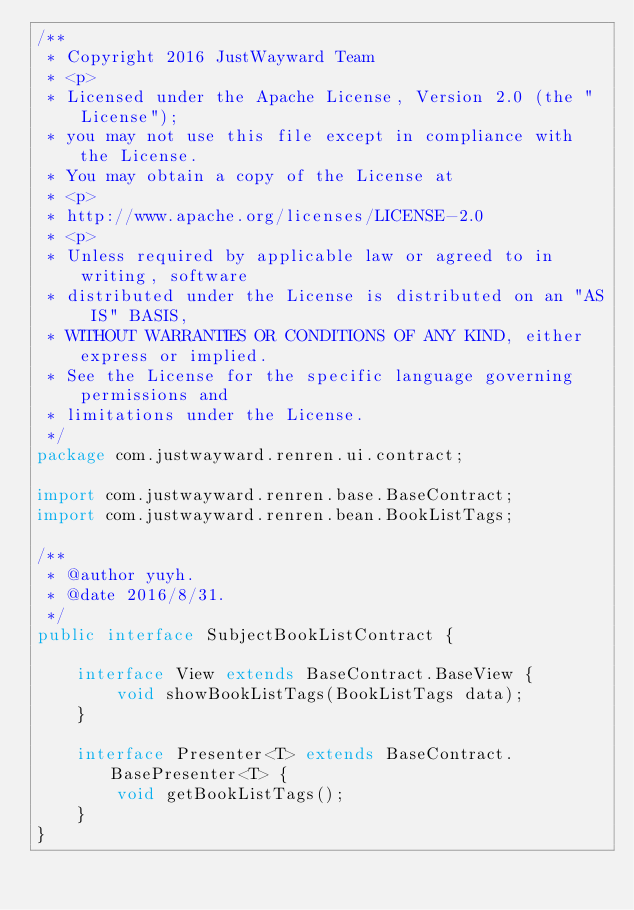<code> <loc_0><loc_0><loc_500><loc_500><_Java_>/**
 * Copyright 2016 JustWayward Team
 * <p>
 * Licensed under the Apache License, Version 2.0 (the "License");
 * you may not use this file except in compliance with the License.
 * You may obtain a copy of the License at
 * <p>
 * http://www.apache.org/licenses/LICENSE-2.0
 * <p>
 * Unless required by applicable law or agreed to in writing, software
 * distributed under the License is distributed on an "AS IS" BASIS,
 * WITHOUT WARRANTIES OR CONDITIONS OF ANY KIND, either express or implied.
 * See the License for the specific language governing permissions and
 * limitations under the License.
 */
package com.justwayward.renren.ui.contract;

import com.justwayward.renren.base.BaseContract;
import com.justwayward.renren.bean.BookListTags;

/**
 * @author yuyh.
 * @date 2016/8/31.
 */
public interface SubjectBookListContract {

    interface View extends BaseContract.BaseView {
        void showBookListTags(BookListTags data);
    }

    interface Presenter<T> extends BaseContract.BasePresenter<T> {
        void getBookListTags();
    }
}
</code> 